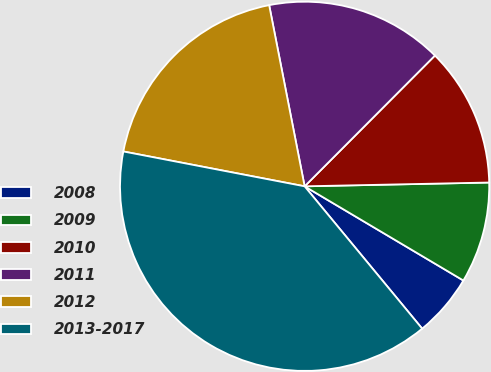Convert chart to OTSL. <chart><loc_0><loc_0><loc_500><loc_500><pie_chart><fcel>2008<fcel>2009<fcel>2010<fcel>2011<fcel>2012<fcel>2013-2017<nl><fcel>5.49%<fcel>8.85%<fcel>12.2%<fcel>15.55%<fcel>18.9%<fcel>39.01%<nl></chart> 